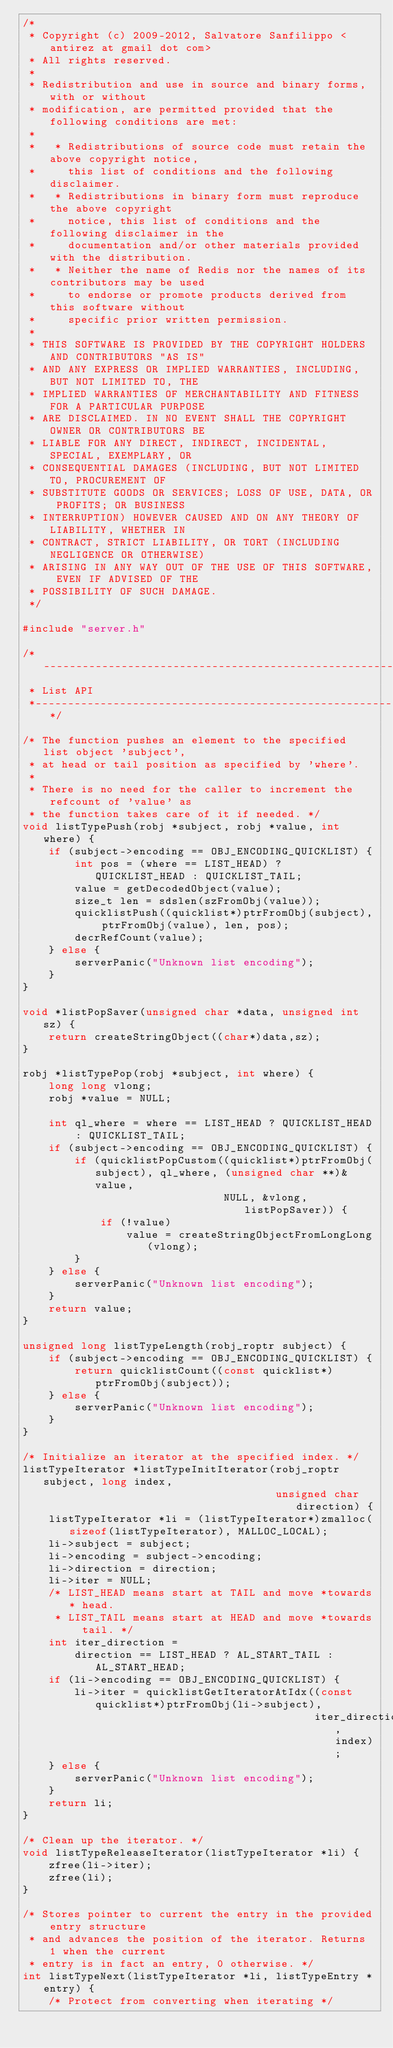<code> <loc_0><loc_0><loc_500><loc_500><_C++_>/*
 * Copyright (c) 2009-2012, Salvatore Sanfilippo <antirez at gmail dot com>
 * All rights reserved.
 *
 * Redistribution and use in source and binary forms, with or without
 * modification, are permitted provided that the following conditions are met:
 *
 *   * Redistributions of source code must retain the above copyright notice,
 *     this list of conditions and the following disclaimer.
 *   * Redistributions in binary form must reproduce the above copyright
 *     notice, this list of conditions and the following disclaimer in the
 *     documentation and/or other materials provided with the distribution.
 *   * Neither the name of Redis nor the names of its contributors may be used
 *     to endorse or promote products derived from this software without
 *     specific prior written permission.
 *
 * THIS SOFTWARE IS PROVIDED BY THE COPYRIGHT HOLDERS AND CONTRIBUTORS "AS IS"
 * AND ANY EXPRESS OR IMPLIED WARRANTIES, INCLUDING, BUT NOT LIMITED TO, THE
 * IMPLIED WARRANTIES OF MERCHANTABILITY AND FITNESS FOR A PARTICULAR PURPOSE
 * ARE DISCLAIMED. IN NO EVENT SHALL THE COPYRIGHT OWNER OR CONTRIBUTORS BE
 * LIABLE FOR ANY DIRECT, INDIRECT, INCIDENTAL, SPECIAL, EXEMPLARY, OR
 * CONSEQUENTIAL DAMAGES (INCLUDING, BUT NOT LIMITED TO, PROCUREMENT OF
 * SUBSTITUTE GOODS OR SERVICES; LOSS OF USE, DATA, OR PROFITS; OR BUSINESS
 * INTERRUPTION) HOWEVER CAUSED AND ON ANY THEORY OF LIABILITY, WHETHER IN
 * CONTRACT, STRICT LIABILITY, OR TORT (INCLUDING NEGLIGENCE OR OTHERWISE)
 * ARISING IN ANY WAY OUT OF THE USE OF THIS SOFTWARE, EVEN IF ADVISED OF THE
 * POSSIBILITY OF SUCH DAMAGE.
 */

#include "server.h"

/*-----------------------------------------------------------------------------
 * List API
 *----------------------------------------------------------------------------*/

/* The function pushes an element to the specified list object 'subject',
 * at head or tail position as specified by 'where'.
 *
 * There is no need for the caller to increment the refcount of 'value' as
 * the function takes care of it if needed. */
void listTypePush(robj *subject, robj *value, int where) {
    if (subject->encoding == OBJ_ENCODING_QUICKLIST) {
        int pos = (where == LIST_HEAD) ? QUICKLIST_HEAD : QUICKLIST_TAIL;
        value = getDecodedObject(value);
        size_t len = sdslen(szFromObj(value));
        quicklistPush((quicklist*)ptrFromObj(subject), ptrFromObj(value), len, pos);
        decrRefCount(value);
    } else {
        serverPanic("Unknown list encoding");
    }
}

void *listPopSaver(unsigned char *data, unsigned int sz) {
    return createStringObject((char*)data,sz);
}

robj *listTypePop(robj *subject, int where) {
    long long vlong;
    robj *value = NULL;

    int ql_where = where == LIST_HEAD ? QUICKLIST_HEAD : QUICKLIST_TAIL;
    if (subject->encoding == OBJ_ENCODING_QUICKLIST) {
        if (quicklistPopCustom((quicklist*)ptrFromObj(subject), ql_where, (unsigned char **)&value,
                               NULL, &vlong, listPopSaver)) {
            if (!value)
                value = createStringObjectFromLongLong(vlong);
        }
    } else {
        serverPanic("Unknown list encoding");
    }
    return value;
}

unsigned long listTypeLength(robj_roptr subject) {
    if (subject->encoding == OBJ_ENCODING_QUICKLIST) {
        return quicklistCount((const quicklist*)ptrFromObj(subject));
    } else {
        serverPanic("Unknown list encoding");
    }
}

/* Initialize an iterator at the specified index. */
listTypeIterator *listTypeInitIterator(robj_roptr subject, long index,
                                       unsigned char direction) {
    listTypeIterator *li = (listTypeIterator*)zmalloc(sizeof(listTypeIterator), MALLOC_LOCAL);
    li->subject = subject;
    li->encoding = subject->encoding;
    li->direction = direction;
    li->iter = NULL;
    /* LIST_HEAD means start at TAIL and move *towards* head.
     * LIST_TAIL means start at HEAD and move *towards tail. */
    int iter_direction =
        direction == LIST_HEAD ? AL_START_TAIL : AL_START_HEAD;
    if (li->encoding == OBJ_ENCODING_QUICKLIST) {
        li->iter = quicklistGetIteratorAtIdx((const quicklist*)ptrFromObj(li->subject),
                                             iter_direction, index);
    } else {
        serverPanic("Unknown list encoding");
    }
    return li;
}

/* Clean up the iterator. */
void listTypeReleaseIterator(listTypeIterator *li) {
    zfree(li->iter);
    zfree(li);
}

/* Stores pointer to current the entry in the provided entry structure
 * and advances the position of the iterator. Returns 1 when the current
 * entry is in fact an entry, 0 otherwise. */
int listTypeNext(listTypeIterator *li, listTypeEntry *entry) {
    /* Protect from converting when iterating */</code> 